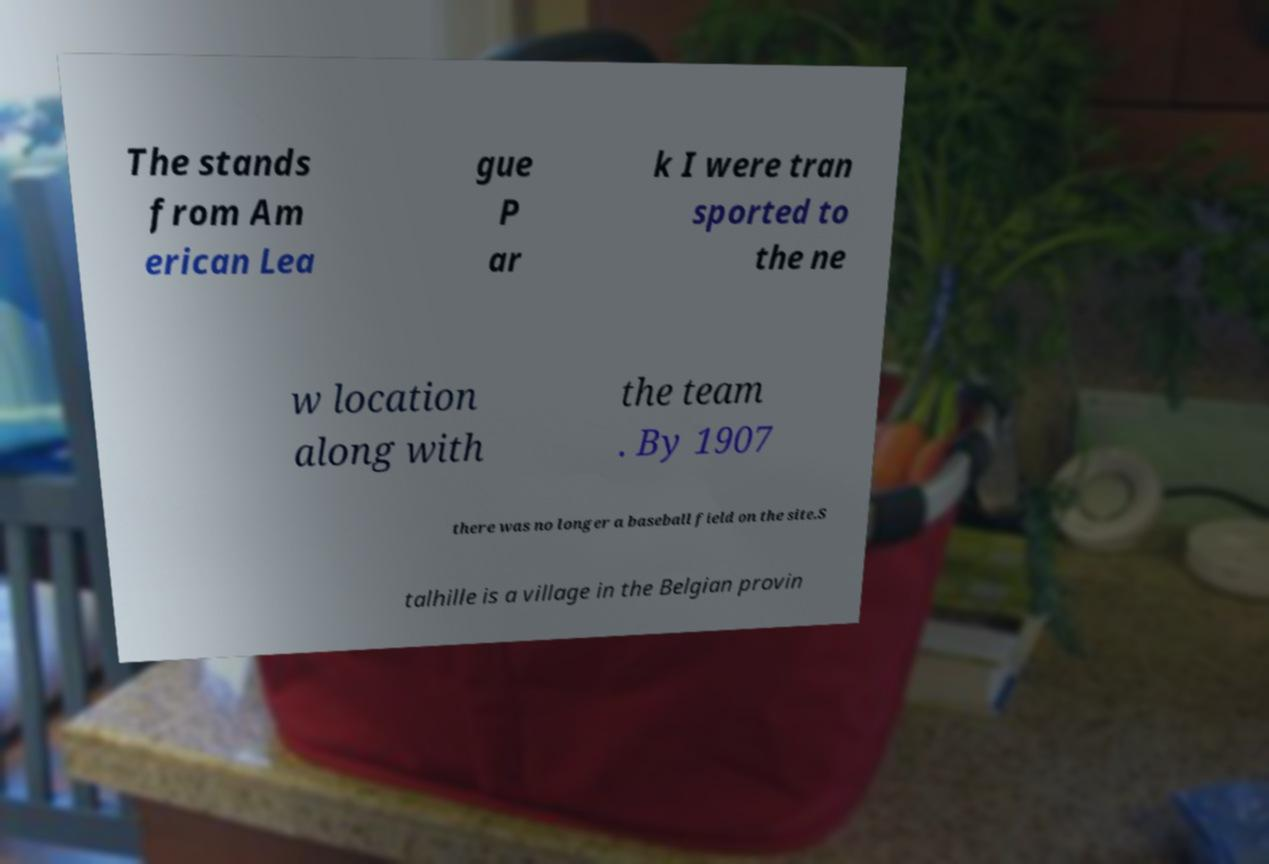I need the written content from this picture converted into text. Can you do that? The stands from Am erican Lea gue P ar k I were tran sported to the ne w location along with the team . By 1907 there was no longer a baseball field on the site.S talhille is a village in the Belgian provin 